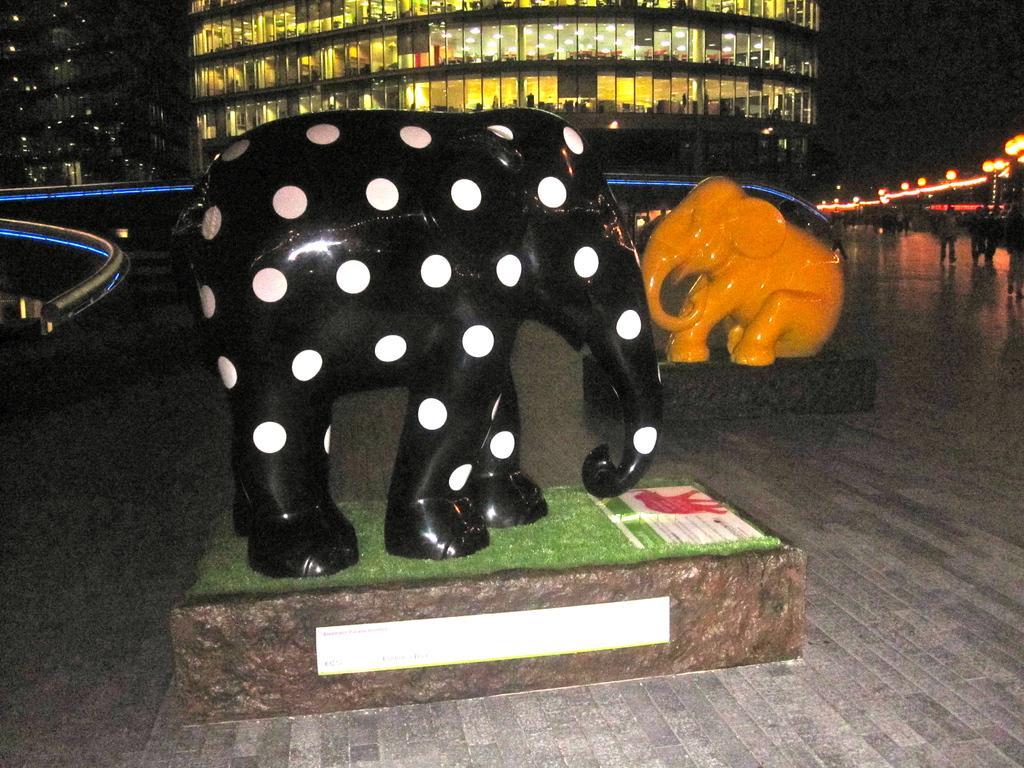Could you give a brief overview of what you see in this image? In the foreground I can see two elephants statues, street lights, fence and a group of people on the road. In the background I can see buildings. This image is taken may be during night. 